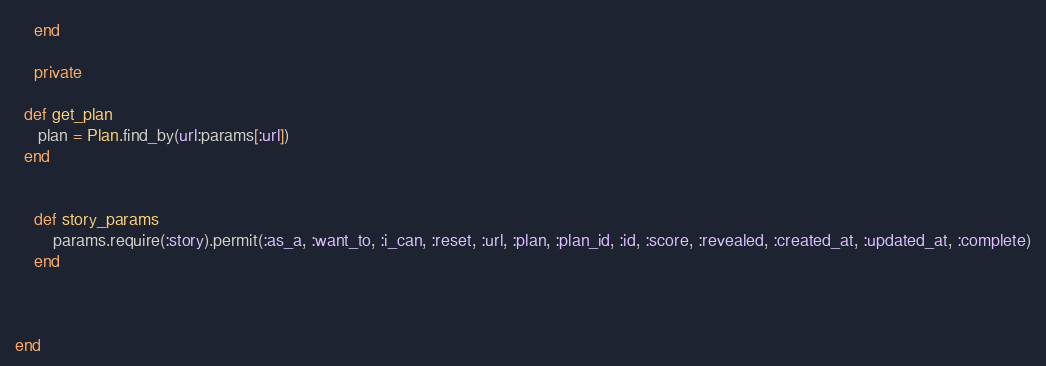Convert code to text. <code><loc_0><loc_0><loc_500><loc_500><_Ruby_>    end

    private
  
  def get_plan
     plan = Plan.find_by(url:params[:url])
  end


    def story_params
        params.require(:story).permit(:as_a, :want_to, :i_can, :reset, :url, :plan, :plan_id, :id, :score, :revealed, :created_at, :updated_at, :complete)
    end

    

end




</code> 